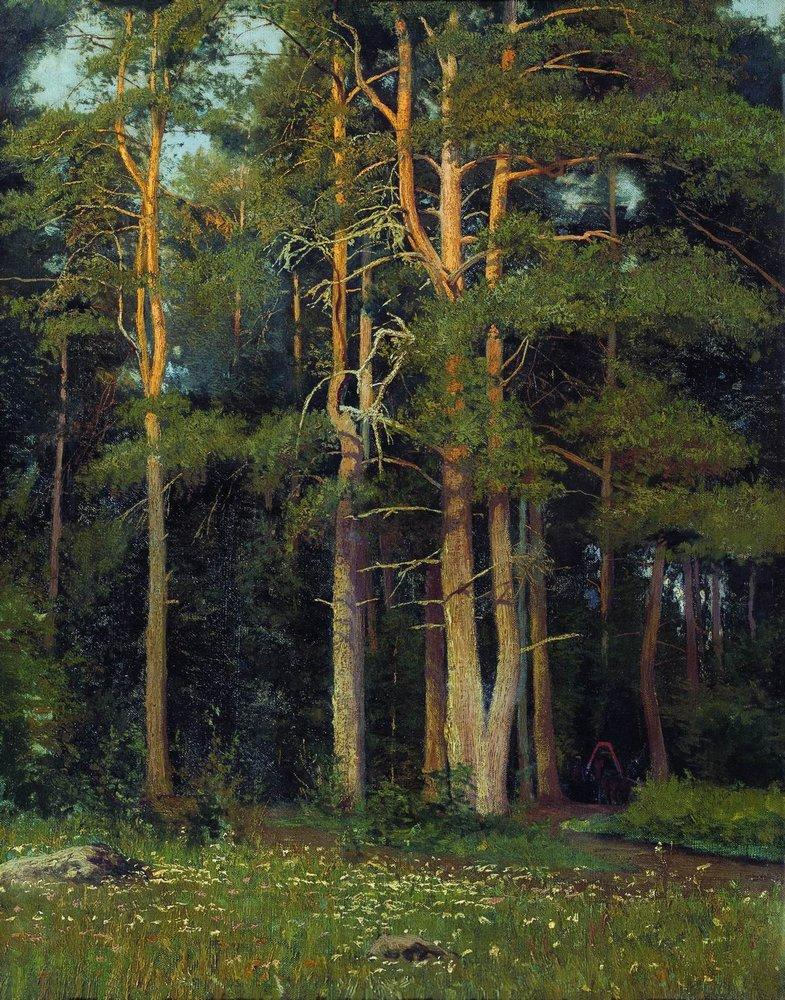Can you describe the main features of this image for me? The image is a captivating oil painting that beautifully portrays a serene forest. The artist masterfully utilizes a realistic style with a prominent palette of greens and browns. The composition features tall trees, each adorned with lush foliage, creating an enveloping canopy. A small clearing in the foreground contrasts with the dense forest, adding a sense of openness. Notably, the trees in the background are painted with darker hues, while those in the foreground appear lighter, a technique which adds depth and directs the viewer's gaze into the heart of the forest. The loose brushwork infuses the scene with a sense of movement and vitality. This painting perfectly encapsulates the essence of the landscape genre, emphasizing the beauty and tranquility of the natural world. 